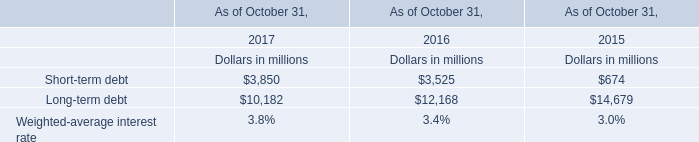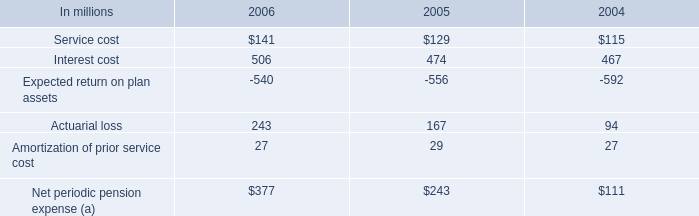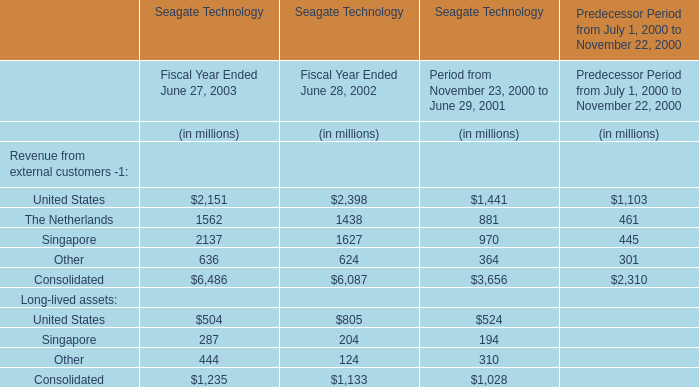what is the percentage change in net periodic pension expense between 2005 and 2006? 
Computations: ((377 - 243) / 243)
Answer: 0.55144. 